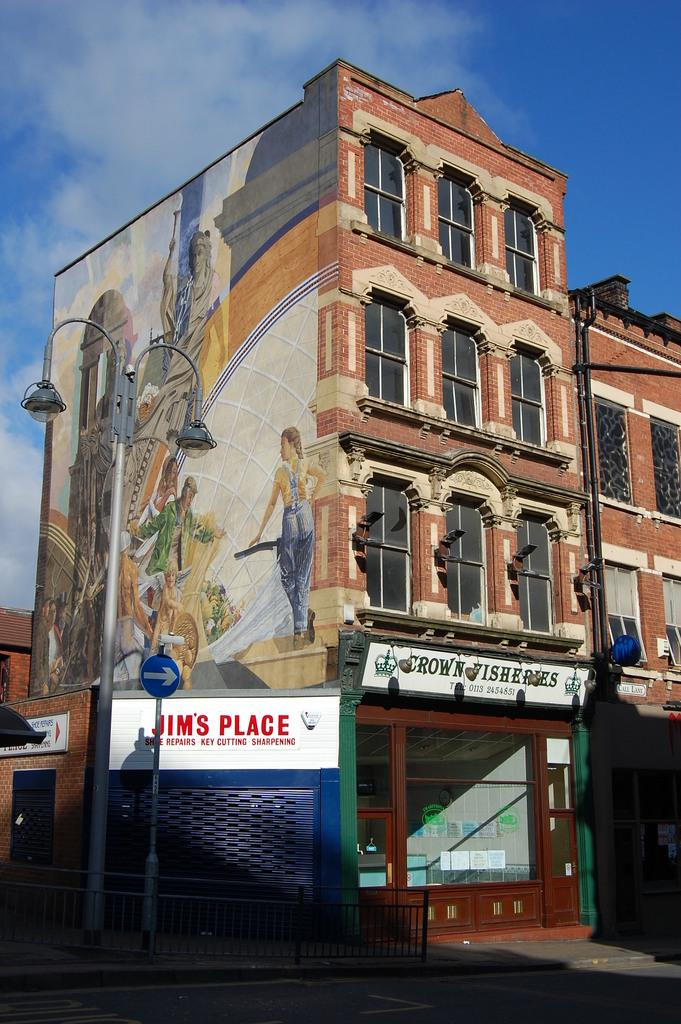What is located in the center of the image? There are buildings in the center of the image. What can be found at the bottom of the image? There are stores and boards at the bottom of the image. What structures are visible in the image? Poles are visible in the image. What type of barrier is present in the image? There is a fence in the image. What can be seen in the background of the image? The sky is visible in the background of the image. What type of news can be heard coming from the buildings in the image? There is no indication in the image that news is being broadcasted or heard from the buildings. How many cakes are visible on the poles in the image? There are no cakes present in the image; only buildings, stores, boards, poles, a fence, and the sky are visible. 